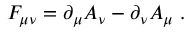<formula> <loc_0><loc_0><loc_500><loc_500>F _ { \mu \nu } = \partial _ { \mu } A _ { \nu } - \partial _ { \nu } A _ { \mu } \, .</formula> 